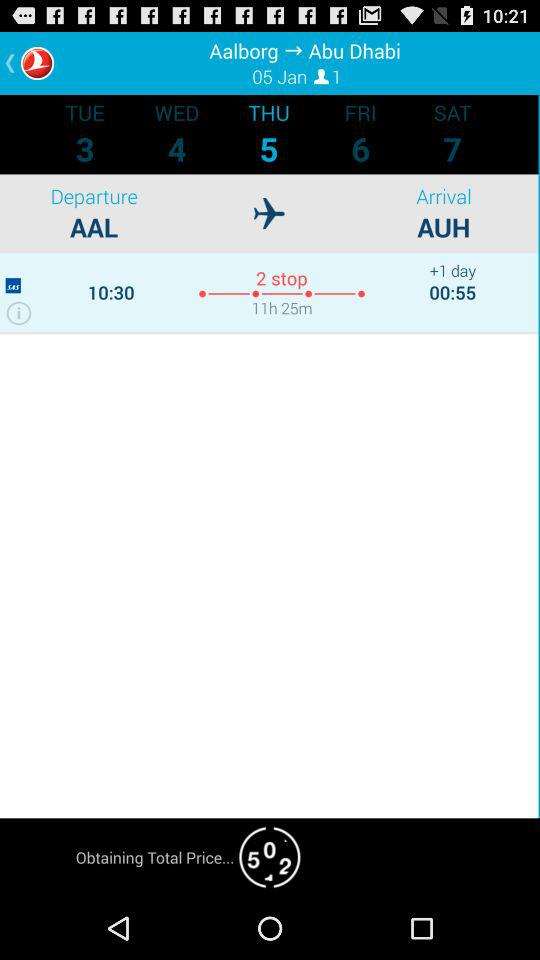How many stops are there? There are 2 stops. 